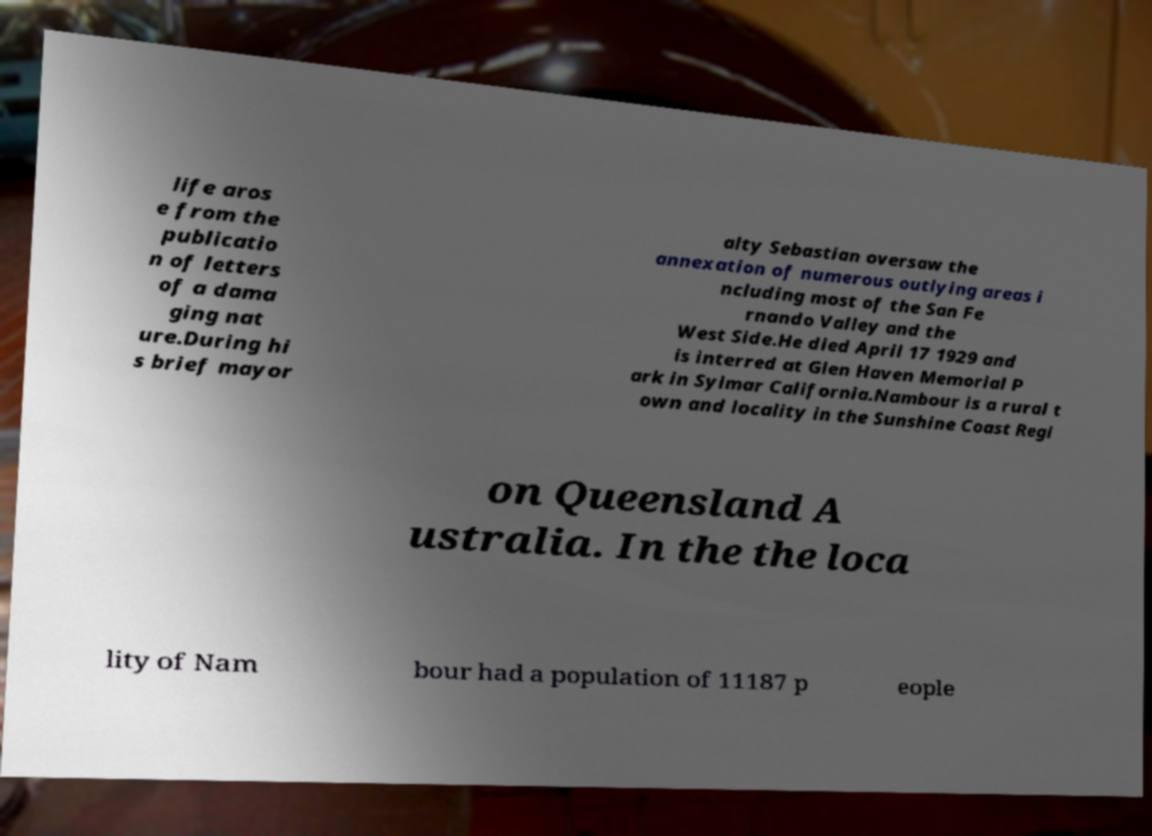Could you assist in decoding the text presented in this image and type it out clearly? life aros e from the publicatio n of letters of a dama ging nat ure.During hi s brief mayor alty Sebastian oversaw the annexation of numerous outlying areas i ncluding most of the San Fe rnando Valley and the West Side.He died April 17 1929 and is interred at Glen Haven Memorial P ark in Sylmar California.Nambour is a rural t own and locality in the Sunshine Coast Regi on Queensland A ustralia. In the the loca lity of Nam bour had a population of 11187 p eople 